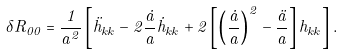Convert formula to latex. <formula><loc_0><loc_0><loc_500><loc_500>\delta R _ { 0 0 } = \frac { 1 } { a ^ { 2 } } \left [ \ddot { h } _ { k k } - 2 \frac { \dot { a } } { a } \dot { h } _ { k k } + 2 \left [ \left ( \frac { \dot { a } } { a } \right ) ^ { 2 } - \frac { \ddot { a } } { a } \right ] h _ { k k } \right ] .</formula> 